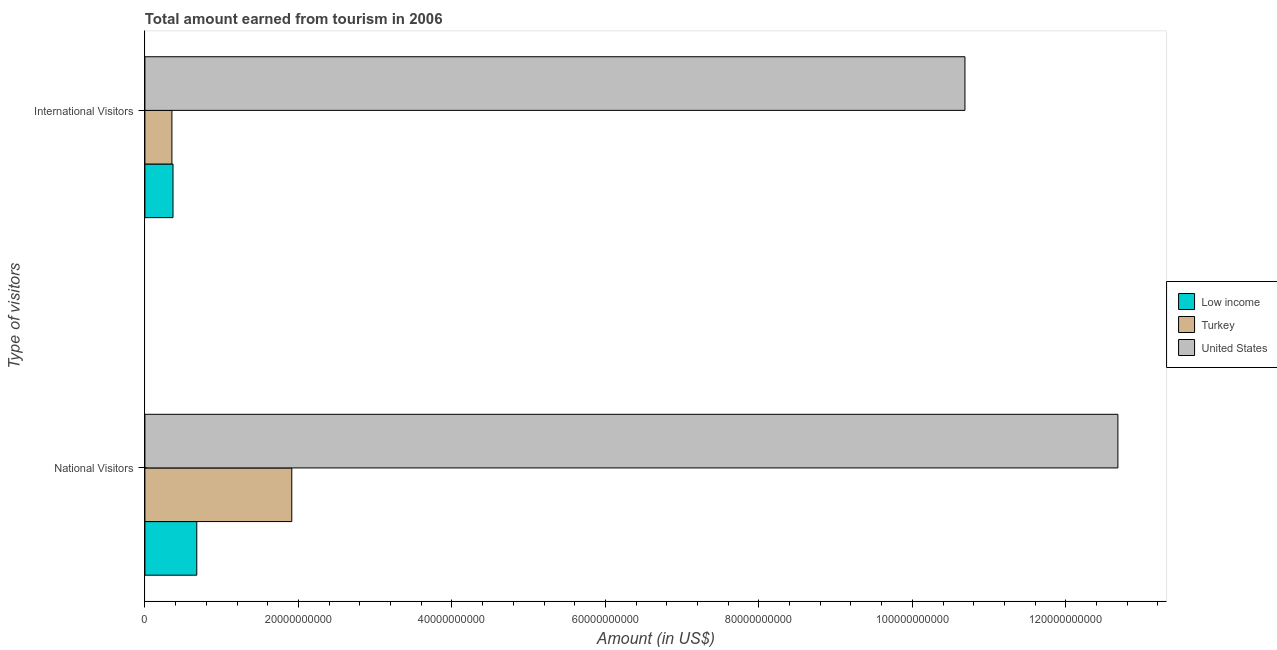How many different coloured bars are there?
Keep it short and to the point. 3. How many groups of bars are there?
Provide a short and direct response. 2. How many bars are there on the 1st tick from the top?
Offer a very short reply. 3. What is the label of the 1st group of bars from the top?
Your answer should be compact. International Visitors. What is the amount earned from national visitors in Turkey?
Your answer should be compact. 1.91e+1. Across all countries, what is the maximum amount earned from national visitors?
Provide a succinct answer. 1.27e+11. Across all countries, what is the minimum amount earned from national visitors?
Keep it short and to the point. 6.76e+09. What is the total amount earned from international visitors in the graph?
Provide a short and direct response. 1.14e+11. What is the difference between the amount earned from national visitors in Low income and that in Turkey?
Provide a succinct answer. -1.24e+1. What is the difference between the amount earned from national visitors in United States and the amount earned from international visitors in Low income?
Provide a succinct answer. 1.23e+11. What is the average amount earned from international visitors per country?
Keep it short and to the point. 3.80e+1. What is the difference between the amount earned from international visitors and amount earned from national visitors in Low income?
Give a very brief answer. -3.10e+09. What is the ratio of the amount earned from international visitors in United States to that in Low income?
Give a very brief answer. 29.18. Is the amount earned from national visitors in Low income less than that in United States?
Make the answer very short. Yes. What does the 3rd bar from the top in National Visitors represents?
Your response must be concise. Low income. What does the 2nd bar from the bottom in National Visitors represents?
Your answer should be compact. Turkey. How many bars are there?
Make the answer very short. 6. What is the difference between two consecutive major ticks on the X-axis?
Offer a terse response. 2.00e+1. Are the values on the major ticks of X-axis written in scientific E-notation?
Ensure brevity in your answer.  No. Does the graph contain any zero values?
Give a very brief answer. No. Does the graph contain grids?
Give a very brief answer. No. Where does the legend appear in the graph?
Provide a succinct answer. Center right. How many legend labels are there?
Your answer should be compact. 3. How are the legend labels stacked?
Your answer should be very brief. Vertical. What is the title of the graph?
Provide a succinct answer. Total amount earned from tourism in 2006. What is the label or title of the X-axis?
Ensure brevity in your answer.  Amount (in US$). What is the label or title of the Y-axis?
Provide a short and direct response. Type of visitors. What is the Amount (in US$) of Low income in National Visitors?
Your response must be concise. 6.76e+09. What is the Amount (in US$) in Turkey in National Visitors?
Offer a very short reply. 1.91e+1. What is the Amount (in US$) of United States in National Visitors?
Your response must be concise. 1.27e+11. What is the Amount (in US$) of Low income in International Visitors?
Make the answer very short. 3.66e+09. What is the Amount (in US$) in Turkey in International Visitors?
Your response must be concise. 3.52e+09. What is the Amount (in US$) of United States in International Visitors?
Offer a terse response. 1.07e+11. Across all Type of visitors, what is the maximum Amount (in US$) of Low income?
Offer a terse response. 6.76e+09. Across all Type of visitors, what is the maximum Amount (in US$) of Turkey?
Your answer should be very brief. 1.91e+1. Across all Type of visitors, what is the maximum Amount (in US$) in United States?
Provide a short and direct response. 1.27e+11. Across all Type of visitors, what is the minimum Amount (in US$) of Low income?
Provide a short and direct response. 3.66e+09. Across all Type of visitors, what is the minimum Amount (in US$) in Turkey?
Give a very brief answer. 3.52e+09. Across all Type of visitors, what is the minimum Amount (in US$) in United States?
Give a very brief answer. 1.07e+11. What is the total Amount (in US$) of Low income in the graph?
Your answer should be compact. 1.04e+1. What is the total Amount (in US$) in Turkey in the graph?
Ensure brevity in your answer.  2.27e+1. What is the total Amount (in US$) in United States in the graph?
Your response must be concise. 2.34e+11. What is the difference between the Amount (in US$) of Low income in National Visitors and that in International Visitors?
Give a very brief answer. 3.10e+09. What is the difference between the Amount (in US$) in Turkey in National Visitors and that in International Visitors?
Keep it short and to the point. 1.56e+1. What is the difference between the Amount (in US$) of United States in National Visitors and that in International Visitors?
Your answer should be very brief. 1.99e+1. What is the difference between the Amount (in US$) of Low income in National Visitors and the Amount (in US$) of Turkey in International Visitors?
Make the answer very short. 3.24e+09. What is the difference between the Amount (in US$) of Low income in National Visitors and the Amount (in US$) of United States in International Visitors?
Ensure brevity in your answer.  -1.00e+11. What is the difference between the Amount (in US$) of Turkey in National Visitors and the Amount (in US$) of United States in International Visitors?
Ensure brevity in your answer.  -8.77e+1. What is the average Amount (in US$) in Low income per Type of visitors?
Your response must be concise. 5.21e+09. What is the average Amount (in US$) of Turkey per Type of visitors?
Your response must be concise. 1.13e+1. What is the average Amount (in US$) of United States per Type of visitors?
Provide a succinct answer. 1.17e+11. What is the difference between the Amount (in US$) of Low income and Amount (in US$) of Turkey in National Visitors?
Your answer should be very brief. -1.24e+1. What is the difference between the Amount (in US$) of Low income and Amount (in US$) of United States in National Visitors?
Your response must be concise. -1.20e+11. What is the difference between the Amount (in US$) in Turkey and Amount (in US$) in United States in National Visitors?
Your answer should be compact. -1.08e+11. What is the difference between the Amount (in US$) in Low income and Amount (in US$) in Turkey in International Visitors?
Keep it short and to the point. 1.45e+08. What is the difference between the Amount (in US$) in Low income and Amount (in US$) in United States in International Visitors?
Ensure brevity in your answer.  -1.03e+11. What is the difference between the Amount (in US$) in Turkey and Amount (in US$) in United States in International Visitors?
Provide a short and direct response. -1.03e+11. What is the ratio of the Amount (in US$) of Low income in National Visitors to that in International Visitors?
Offer a terse response. 1.85. What is the ratio of the Amount (in US$) in Turkey in National Visitors to that in International Visitors?
Ensure brevity in your answer.  5.44. What is the ratio of the Amount (in US$) in United States in National Visitors to that in International Visitors?
Make the answer very short. 1.19. What is the difference between the highest and the second highest Amount (in US$) of Low income?
Make the answer very short. 3.10e+09. What is the difference between the highest and the second highest Amount (in US$) of Turkey?
Offer a terse response. 1.56e+1. What is the difference between the highest and the second highest Amount (in US$) of United States?
Your answer should be very brief. 1.99e+1. What is the difference between the highest and the lowest Amount (in US$) in Low income?
Provide a succinct answer. 3.10e+09. What is the difference between the highest and the lowest Amount (in US$) of Turkey?
Your answer should be compact. 1.56e+1. What is the difference between the highest and the lowest Amount (in US$) of United States?
Your answer should be compact. 1.99e+1. 